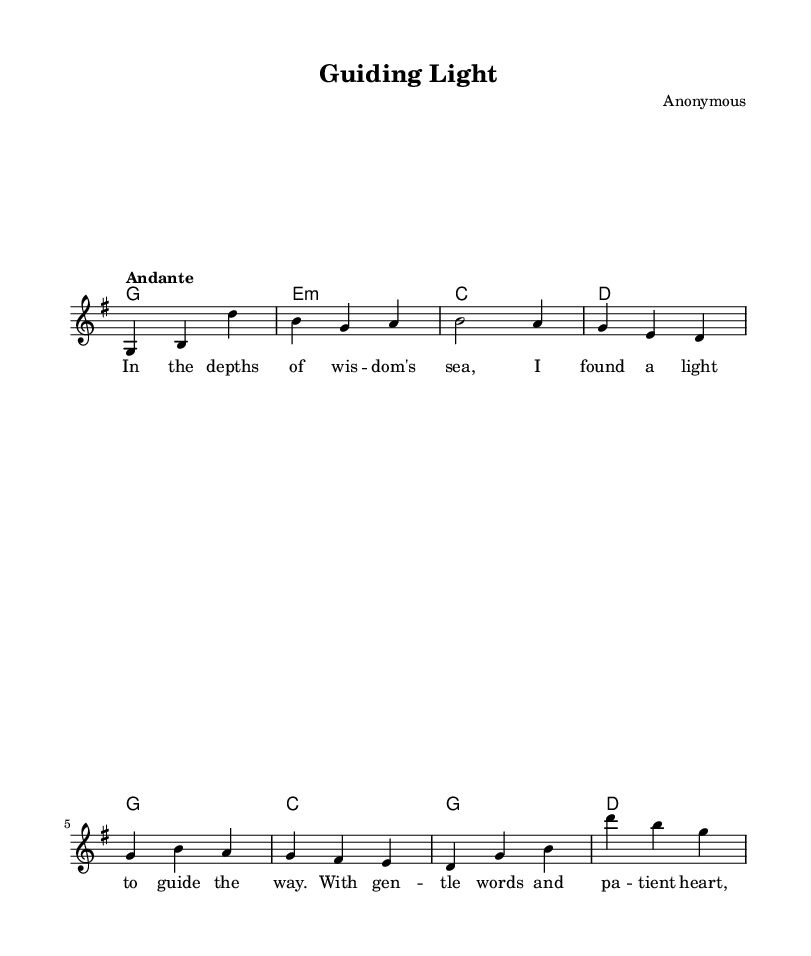What is the key signature of this music? The key signature is indicated at the beginning of the piece, where you can see one sharp (F#), which corresponds to G major.
Answer: G major What is the time signature of this music? The time signature appears at the start of the music. In this case, it is 3/4, which means there are three beats in each measure.
Answer: 3/4 What is the tempo marking for this piece? The tempo is provided at the start of the score, and it states "Andante," which indicates a moderate pace.
Answer: Andante How many measures are in the melody section? By counting the individual measures in the melody section written out, we see there are four distinct measures.
Answer: Four Which chord is used at the beginning of the piece? The first chord defined in the chord mode is G major, which includes the notes G, B, and D. It is the first chord in the sequence.
Answer: G What emotion or theme does this folk piece convey through its lyrics? Examining the lyrics, they suggest themes of guidance and support, emphasizing wisdom and patience in helping others. The narrative centers on mentorship.
Answer: Mentorship Why is the 3/4 time signature significant in folk music? The 3/4 time signature is often used in folk music to create a waltz-like feel, providing a flowing rhythm that complements the storytelling nature of folk narratives. This adds to the overall emotional expression and makes it suitable for dancing or gentle movement.
Answer: Waltz-like feel 